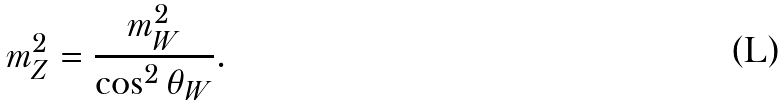Convert formula to latex. <formula><loc_0><loc_0><loc_500><loc_500>m _ { Z } ^ { 2 } = \frac { m _ { W } ^ { 2 } } { \cos ^ { 2 } \theta _ { W } } .</formula> 